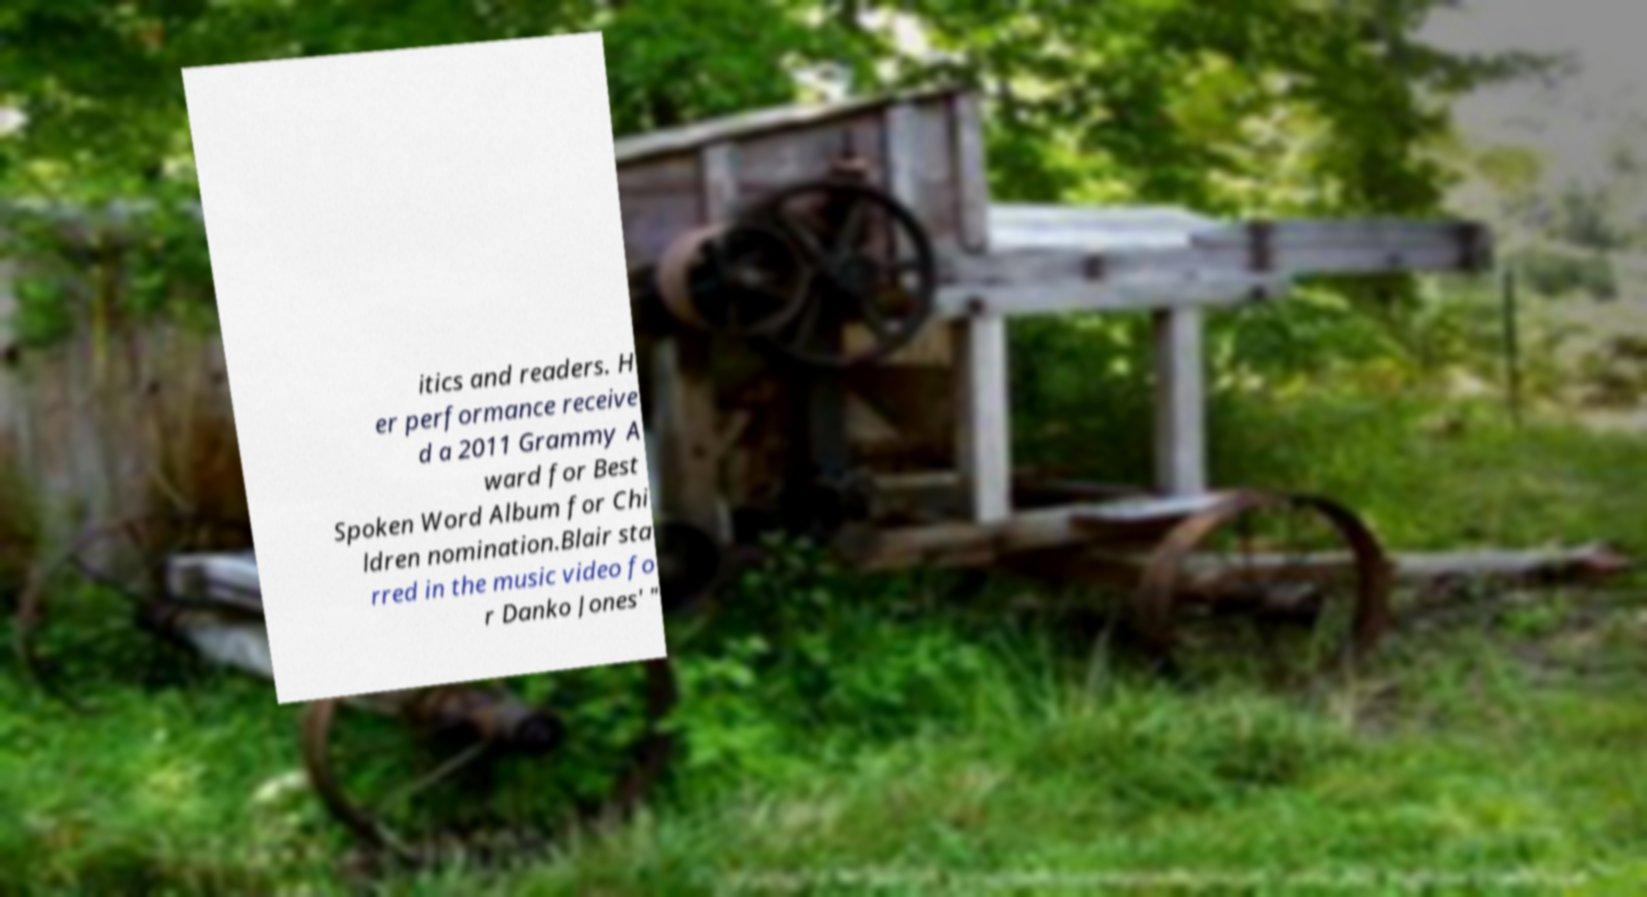Can you read and provide the text displayed in the image?This photo seems to have some interesting text. Can you extract and type it out for me? itics and readers. H er performance receive d a 2011 Grammy A ward for Best Spoken Word Album for Chi ldren nomination.Blair sta rred in the music video fo r Danko Jones' " 